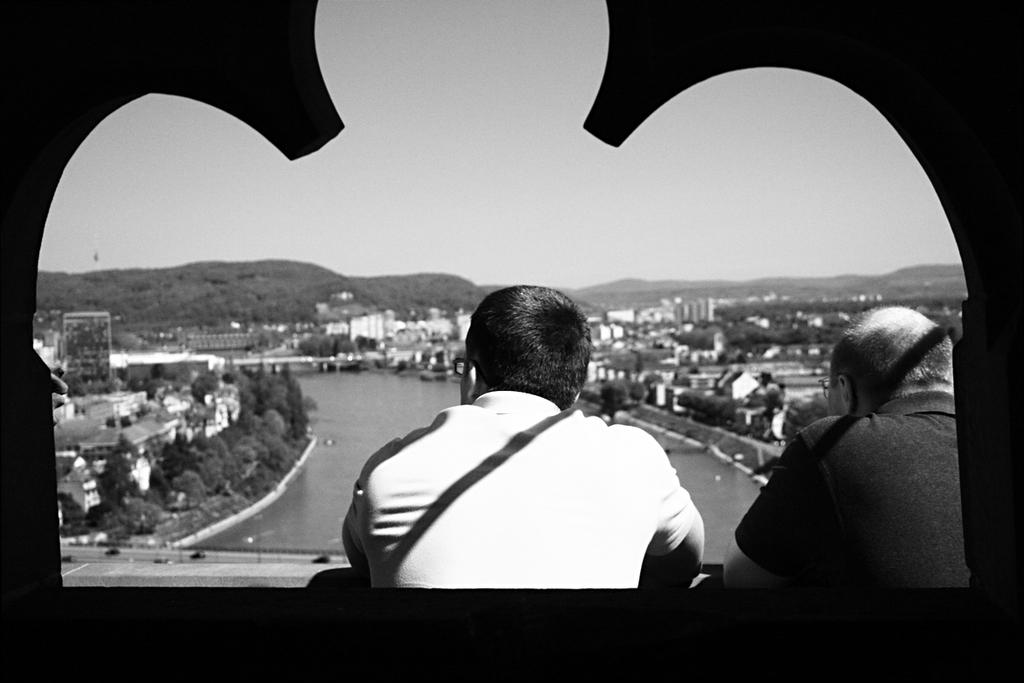How many people are present in the image? There are two people in the image. What type of natural environment can be seen in the image? Trees and a mountain are visible in the image. What type of man-made structures can be seen in the image? Buildings are visible in the image. What type of water feature can be seen in the image? Water is visible in the image. How much money is being exchanged between the two people in the image? There is no indication of money or any exchange taking place in the image. Can you see a rat in the image? There is no rat present in the image. 